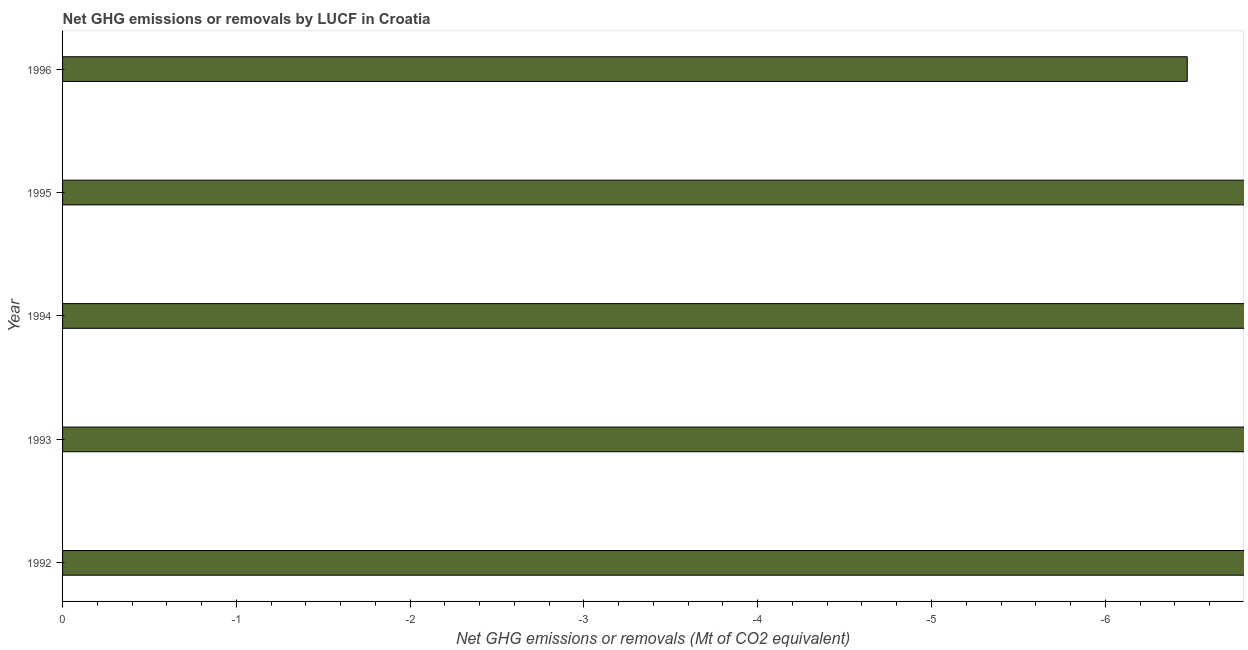Does the graph contain grids?
Keep it short and to the point. No. What is the title of the graph?
Offer a terse response. Net GHG emissions or removals by LUCF in Croatia. What is the label or title of the X-axis?
Offer a terse response. Net GHG emissions or removals (Mt of CO2 equivalent). What is the label or title of the Y-axis?
Your response must be concise. Year. What is the ghg net emissions or removals in 1996?
Offer a very short reply. 0. What is the sum of the ghg net emissions or removals?
Keep it short and to the point. 0. In how many years, is the ghg net emissions or removals greater than -1 Mt?
Provide a succinct answer. 0. Are all the bars in the graph horizontal?
Give a very brief answer. Yes. What is the difference between two consecutive major ticks on the X-axis?
Ensure brevity in your answer.  1. Are the values on the major ticks of X-axis written in scientific E-notation?
Offer a terse response. No. What is the Net GHG emissions or removals (Mt of CO2 equivalent) of 1992?
Provide a short and direct response. 0. What is the Net GHG emissions or removals (Mt of CO2 equivalent) of 1994?
Provide a succinct answer. 0. What is the Net GHG emissions or removals (Mt of CO2 equivalent) of 1995?
Offer a very short reply. 0. What is the Net GHG emissions or removals (Mt of CO2 equivalent) in 1996?
Your response must be concise. 0. 